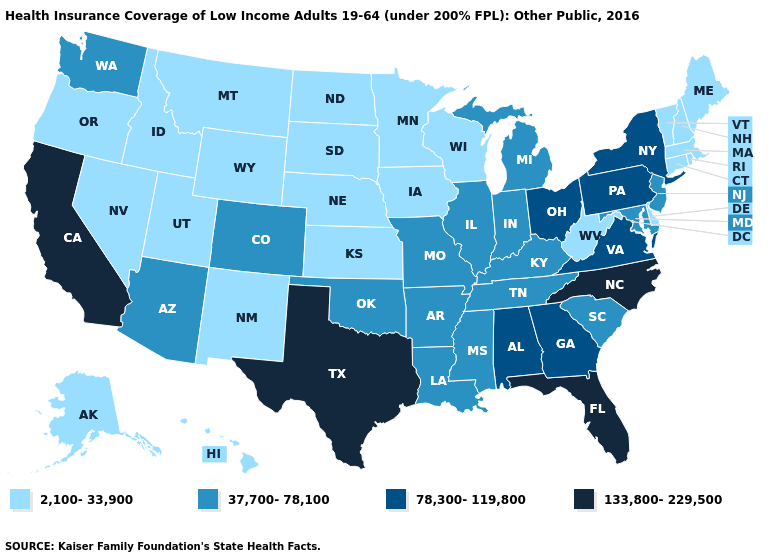What is the highest value in the South ?
Write a very short answer. 133,800-229,500. Which states have the lowest value in the West?
Quick response, please. Alaska, Hawaii, Idaho, Montana, Nevada, New Mexico, Oregon, Utah, Wyoming. How many symbols are there in the legend?
Short answer required. 4. Does Pennsylvania have the lowest value in the Northeast?
Give a very brief answer. No. Does Texas have the lowest value in the USA?
Quick response, please. No. Does Illinois have the lowest value in the MidWest?
Short answer required. No. What is the value of Kentucky?
Short answer required. 37,700-78,100. Does West Virginia have the lowest value in the South?
Write a very short answer. Yes. Name the states that have a value in the range 133,800-229,500?
Keep it brief. California, Florida, North Carolina, Texas. Among the states that border Georgia , which have the lowest value?
Give a very brief answer. South Carolina, Tennessee. Which states have the lowest value in the USA?
Short answer required. Alaska, Connecticut, Delaware, Hawaii, Idaho, Iowa, Kansas, Maine, Massachusetts, Minnesota, Montana, Nebraska, Nevada, New Hampshire, New Mexico, North Dakota, Oregon, Rhode Island, South Dakota, Utah, Vermont, West Virginia, Wisconsin, Wyoming. What is the value of Kansas?
Be succinct. 2,100-33,900. What is the lowest value in the USA?
Keep it brief. 2,100-33,900. What is the value of Missouri?
Keep it brief. 37,700-78,100. 